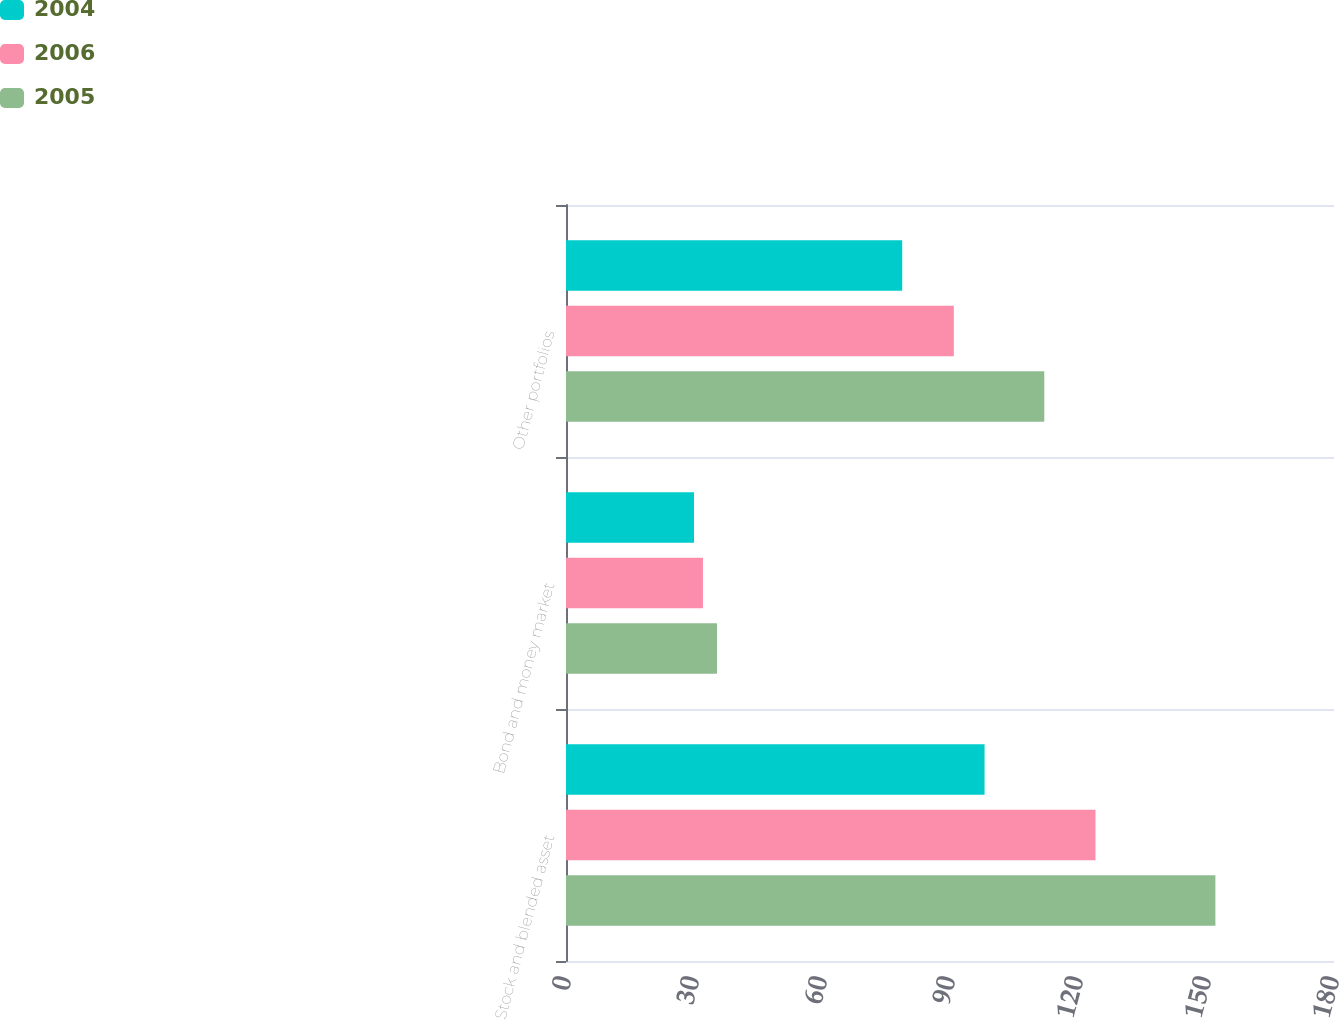<chart> <loc_0><loc_0><loc_500><loc_500><stacked_bar_chart><ecel><fcel>Stock and blended asset<fcel>Bond and money market<fcel>Other portfolios<nl><fcel>2004<fcel>98.1<fcel>30<fcel>78.8<nl><fcel>2006<fcel>124.1<fcel>32.1<fcel>90.9<nl><fcel>2005<fcel>152.2<fcel>35.4<fcel>112.1<nl></chart> 